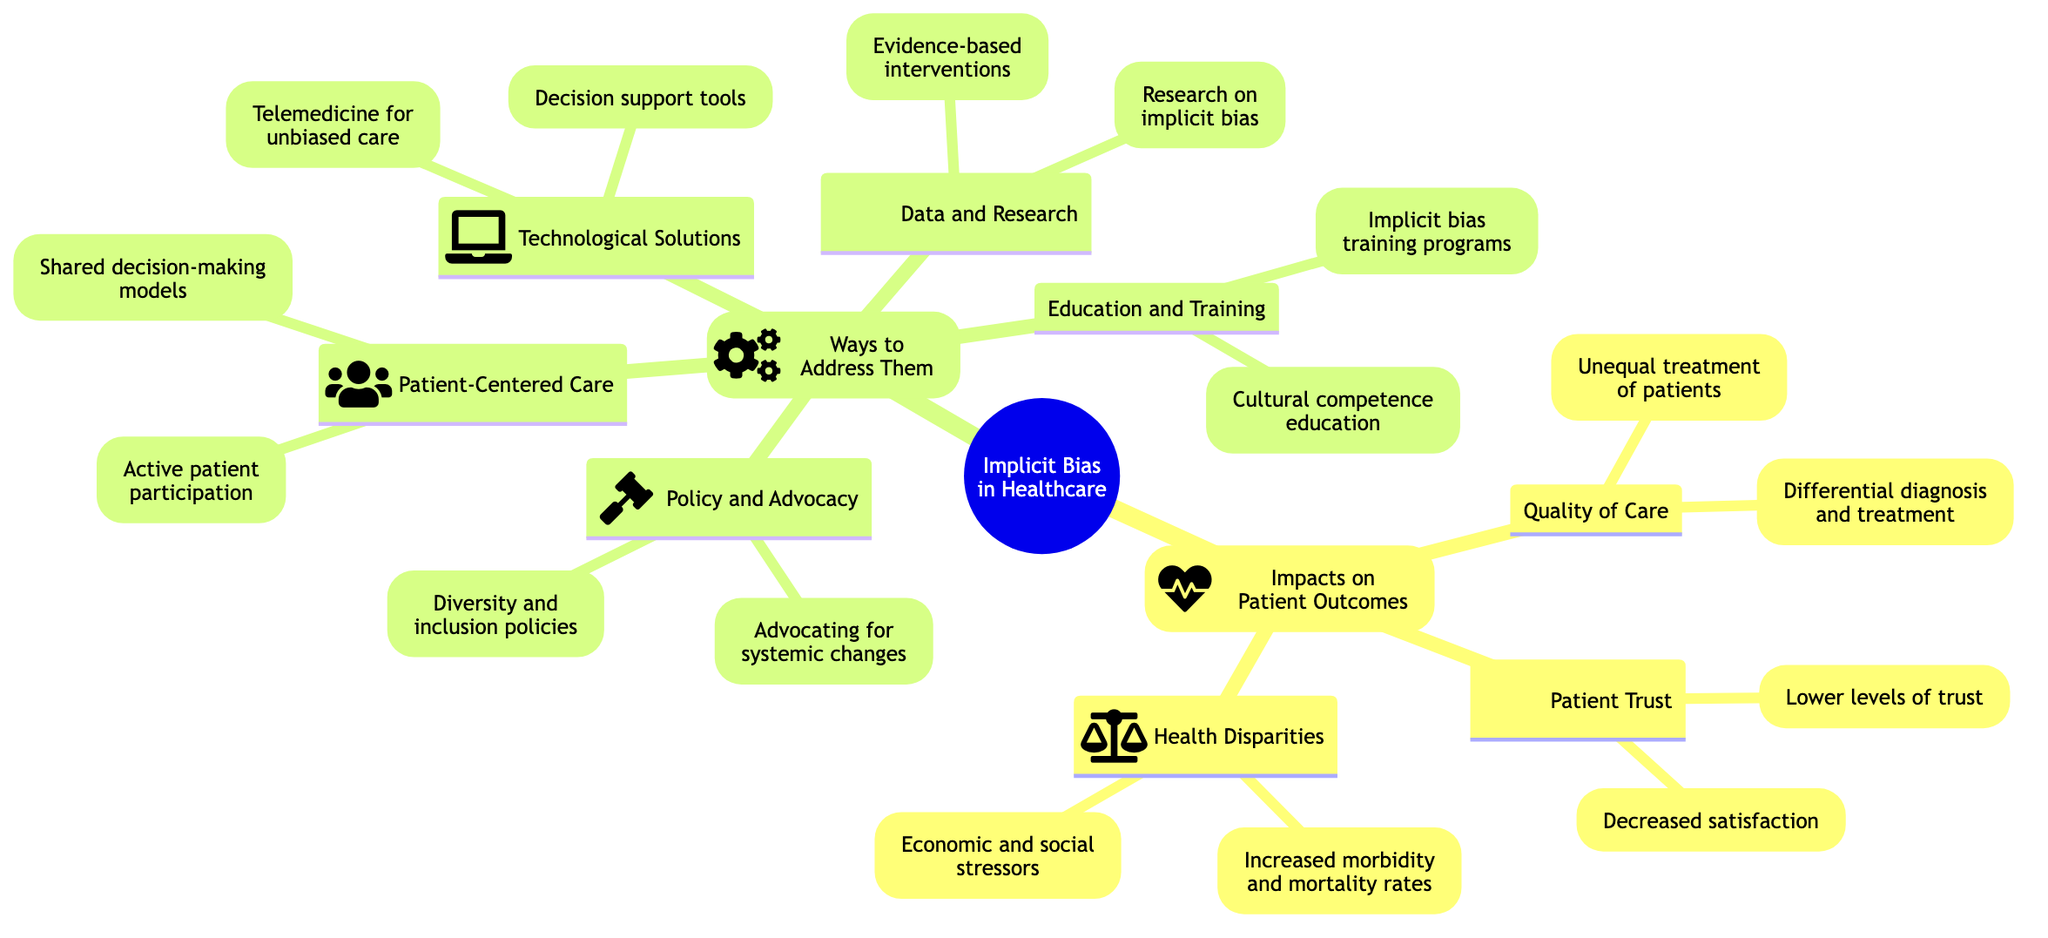What are the main branches of the mind map? The main branches can be identified as 'Impacts on Patient Outcomes' and 'Ways to Address Them,' which directly stem from the central concept of 'Implicit Bias in Healthcare.'
Answer: Impacts on Patient Outcomes, Ways to Address Them How many sub-branches are under 'Impacts on Patient Outcomes'? Under 'Impacts on Patient Outcomes,' there are three sub-branches: 'Quality of Care,' 'Patient Trust,' and 'Health Disparities.' Counting these gives us a total of three.
Answer: 3 What does 'Quality of Care' include as its elements? The elements under 'Quality of Care' include 'Unequal treatment of patients based on race, gender, and socioeconomic status' and 'Differential diagnosis and treatment options.'
Answer: Unequal treatment, Differential diagnosis Which branch discusses the effects on patient trust? The branch that discusses the effects on patient trust is 'Patient Trust,' which highlights issues such as lower levels of trust and decreased patient satisfaction.
Answer: Patient Trust How many elements are in the 'Technological Solutions' sub-branch? The 'Technological Solutions' sub-branch contains two elements: 'Deploying decision support tools to minimize biases in clinical decision-making' and 'Leveraging telemedicine to provide unbiased care.' Therefore, there are two elements.
Answer: 2 What type of training is suggested to combat implicit bias in healthcare? The mind map suggests that implementing 'implicit bias training programs in medical schools and hospitals' is a way to address implicit bias in healthcare.
Answer: Implicit bias training programs Which branch includes 'Cultural competence education'? 'Cultural competence education' is included under the 'Education and Training' branch, which aims to address implicit bias through educational initiatives.
Answer: Education and Training What is a key focus of 'Patient-Centered Care'? A key focus of 'Patient-Centered Care' is encouraging 'active patient participation in their care,' promoting communication and collaboration between patients and healthcare providers.
Answer: Active patient participation How does the 'Policy and Advocacy' branch aim to address health disparities? The 'Policy and Advocacy' branch aims to address health disparities through adopting 'diversity and inclusion policies' and advocating for 'systemic changes to address health disparities,' highlighting the importance of policy interventions.
Answer: Diversity and inclusion policies, Systemic changes 